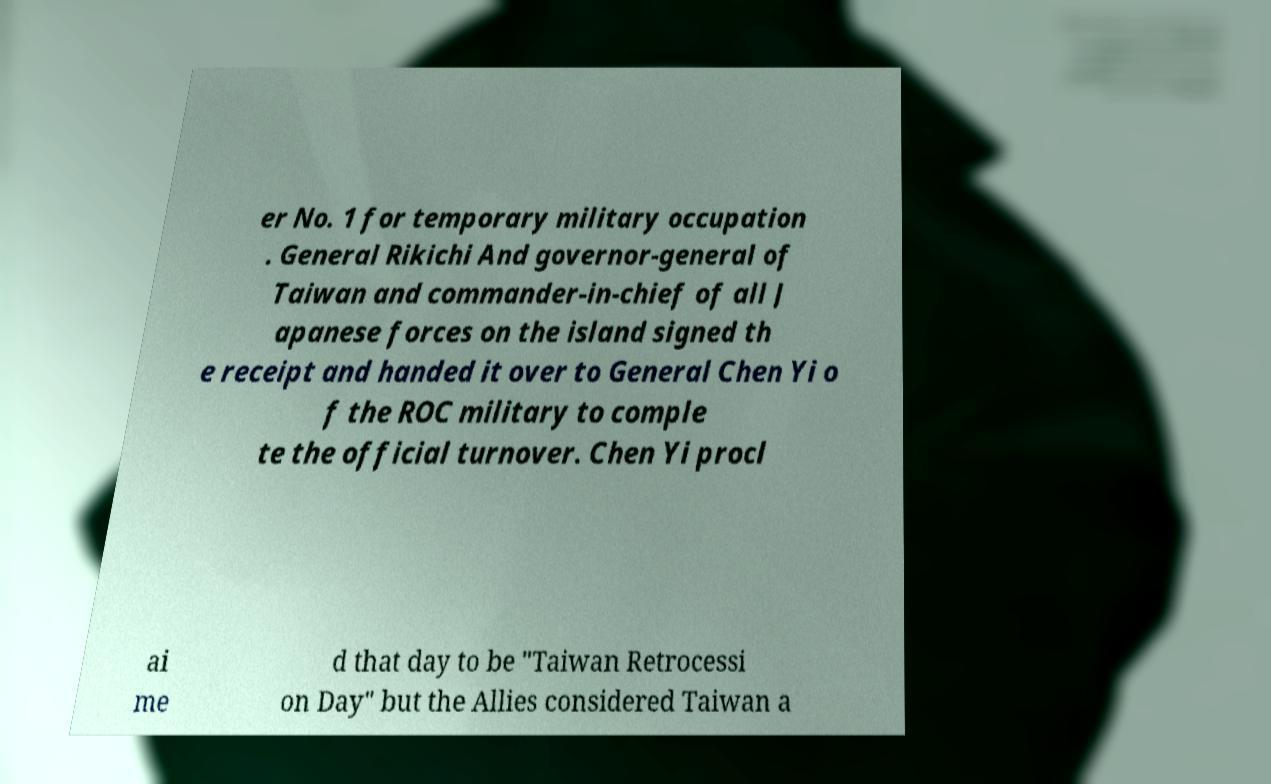Please read and relay the text visible in this image. What does it say? er No. 1 for temporary military occupation . General Rikichi And governor-general of Taiwan and commander-in-chief of all J apanese forces on the island signed th e receipt and handed it over to General Chen Yi o f the ROC military to comple te the official turnover. Chen Yi procl ai me d that day to be "Taiwan Retrocessi on Day" but the Allies considered Taiwan a 